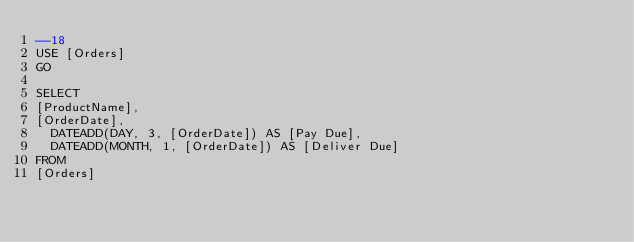<code> <loc_0><loc_0><loc_500><loc_500><_SQL_>--18
USE [Orders]
GO

SELECT 
[ProductName],
[OrderDate],
	DATEADD(DAY, 3, [OrderDate]) AS [Pay Due],
	DATEADD(MONTH, 1, [OrderDate]) AS [Deliver Due]
FROM
[Orders]
	</code> 